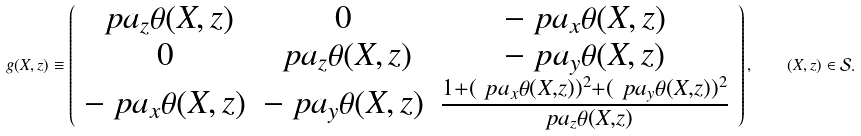<formula> <loc_0><loc_0><loc_500><loc_500>g ( X , z ) \equiv \left ( \begin{array} { c c c } \ p a _ { z } \theta ( X , z ) & 0 & - \ p a _ { x } \theta ( X , z ) \\ 0 & \ p a _ { z } \theta ( X , z ) & - \ p a _ { y } \theta ( X , z ) \\ - \ p a _ { x } \theta ( X , z ) & - \ p a _ { y } \theta ( X , z ) & \frac { 1 + ( \ p a _ { x } \theta ( X , z ) ) ^ { 2 } + ( \ p a _ { y } \theta ( X , z ) ) ^ { 2 } } { \ p a _ { z } \theta ( X , z ) } \end{array} \right ) , \quad ( X , z ) \in \mathcal { S } .</formula> 